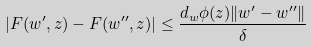<formula> <loc_0><loc_0><loc_500><loc_500>| F ( w ^ { \prime } , z ) - F ( w ^ { \prime \prime } , z ) | \leq \frac { d _ { w } \phi ( z ) \| w ^ { \prime } - w ^ { \prime \prime } \| } { \delta }</formula> 